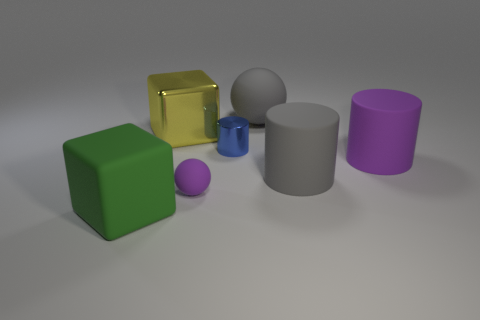What number of metallic objects are the same color as the small rubber object?
Your response must be concise. 0. What number of small purple matte things are there?
Provide a succinct answer. 1. How many big brown things have the same material as the big green block?
Your answer should be compact. 0. The blue metallic thing that is the same shape as the big purple thing is what size?
Make the answer very short. Small. What material is the blue object?
Keep it short and to the point. Metal. What material is the object on the left side of the large cube on the right side of the large thing that is left of the yellow block?
Provide a succinct answer. Rubber. Are there the same number of rubber balls and rubber cubes?
Provide a succinct answer. No. Are there any other things that have the same shape as the small blue metallic object?
Your answer should be compact. Yes. What color is the other large thing that is the same shape as the green object?
Your response must be concise. Yellow. There is a big cube in front of the tiny purple object; does it have the same color as the rubber ball behind the large yellow metallic block?
Ensure brevity in your answer.  No. 